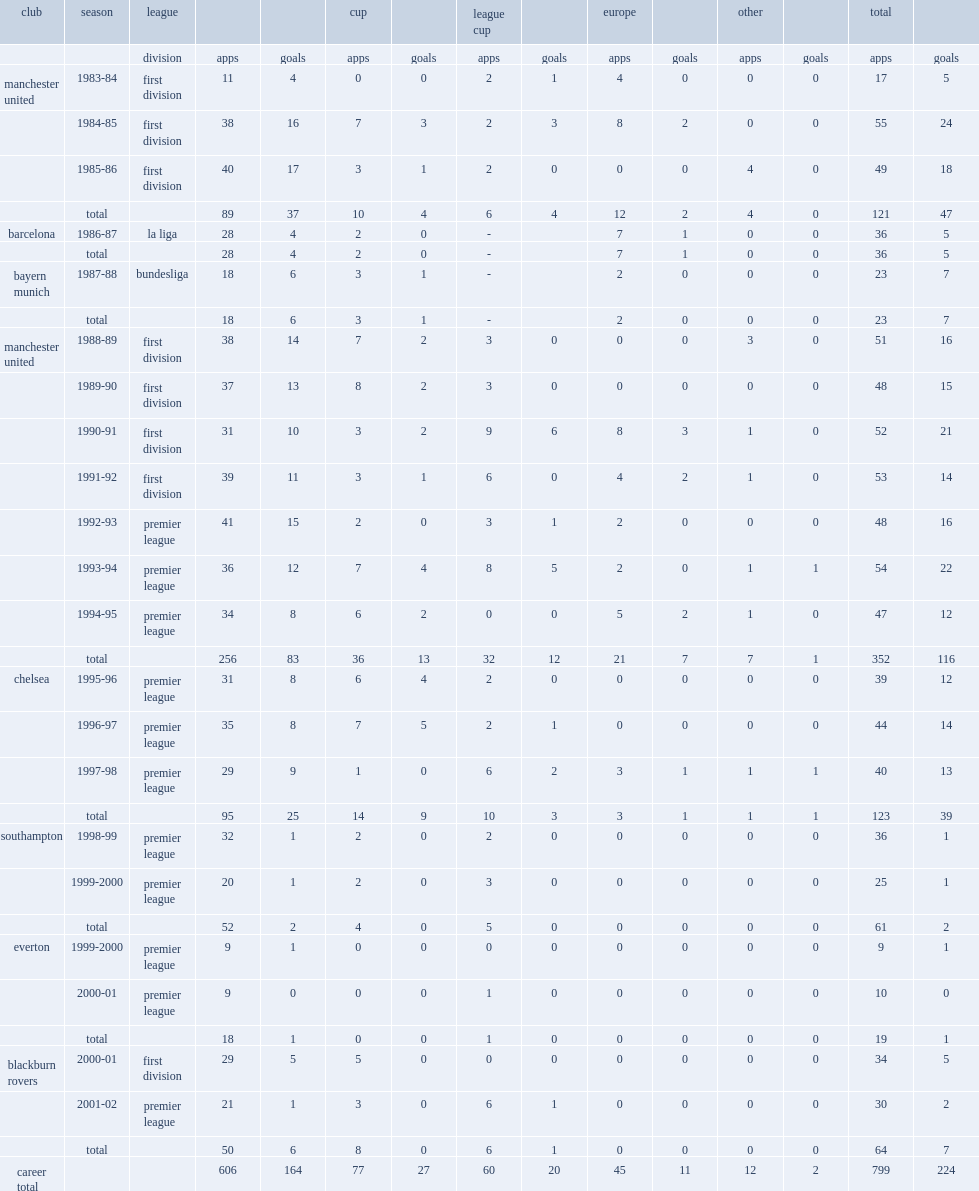Can you parse all the data within this table? {'header': ['club', 'season', 'league', '', '', 'cup', '', 'league cup', '', 'europe', '', 'other', '', 'total', ''], 'rows': [['', '', 'division', 'apps', 'goals', 'apps', 'goals', 'apps', 'goals', 'apps', 'goals', 'apps', 'goals', 'apps', 'goals'], ['manchester united', '1983-84', 'first division', '11', '4', '0', '0', '2', '1', '4', '0', '0', '0', '17', '5'], ['', '1984-85', 'first division', '38', '16', '7', '3', '2', '3', '8', '2', '0', '0', '55', '24'], ['', '1985-86', 'first division', '40', '17', '3', '1', '2', '0', '0', '0', '4', '0', '49', '18'], ['', 'total', '', '89', '37', '10', '4', '6', '4', '12', '2', '4', '0', '121', '47'], ['barcelona', '1986-87', 'la liga', '28', '4', '2', '0', '-', '', '7', '1', '0', '0', '36', '5'], ['', 'total', '', '28', '4', '2', '0', '-', '', '7', '1', '0', '0', '36', '5'], ['bayern munich', '1987-88', 'bundesliga', '18', '6', '3', '1', '-', '', '2', '0', '0', '0', '23', '7'], ['', 'total', '', '18', '6', '3', '1', '-', '', '2', '0', '0', '0', '23', '7'], ['manchester united', '1988-89', 'first division', '38', '14', '7', '2', '3', '0', '0', '0', '3', '0', '51', '16'], ['', '1989-90', 'first division', '37', '13', '8', '2', '3', '0', '0', '0', '0', '0', '48', '15'], ['', '1990-91', 'first division', '31', '10', '3', '2', '9', '6', '8', '3', '1', '0', '52', '21'], ['', '1991-92', 'first division', '39', '11', '3', '1', '6', '0', '4', '2', '1', '0', '53', '14'], ['', '1992-93', 'premier league', '41', '15', '2', '0', '3', '1', '2', '0', '0', '0', '48', '16'], ['', '1993-94', 'premier league', '36', '12', '7', '4', '8', '5', '2', '0', '1', '1', '54', '22'], ['', '1994-95', 'premier league', '34', '8', '6', '2', '0', '0', '5', '2', '1', '0', '47', '12'], ['', 'total', '', '256', '83', '36', '13', '32', '12', '21', '7', '7', '1', '352', '116'], ['chelsea', '1995-96', 'premier league', '31', '8', '6', '4', '2', '0', '0', '0', '0', '0', '39', '12'], ['', '1996-97', 'premier league', '35', '8', '7', '5', '2', '1', '0', '0', '0', '0', '44', '14'], ['', '1997-98', 'premier league', '29', '9', '1', '0', '6', '2', '3', '1', '1', '1', '40', '13'], ['', 'total', '', '95', '25', '14', '9', '10', '3', '3', '1', '1', '1', '123', '39'], ['southampton', '1998-99', 'premier league', '32', '1', '2', '0', '2', '0', '0', '0', '0', '0', '36', '1'], ['', '1999-2000', 'premier league', '20', '1', '2', '0', '3', '0', '0', '0', '0', '0', '25', '1'], ['', 'total', '', '52', '2', '4', '0', '5', '0', '0', '0', '0', '0', '61', '2'], ['everton', '1999-2000', 'premier league', '9', '1', '0', '0', '0', '0', '0', '0', '0', '0', '9', '1'], ['', '2000-01', 'premier league', '9', '0', '0', '0', '1', '0', '0', '0', '0', '0', '10', '0'], ['', 'total', '', '18', '1', '0', '0', '1', '0', '0', '0', '0', '0', '19', '1'], ['blackburn rovers', '2000-01', 'first division', '29', '5', '5', '0', '0', '0', '0', '0', '0', '0', '34', '5'], ['', '2001-02', 'premier league', '21', '1', '3', '0', '6', '1', '0', '0', '0', '0', '30', '2'], ['', 'total', '', '50', '6', '8', '0', '6', '1', '0', '0', '0', '0', '64', '7'], ['career total', '', '', '606', '164', '77', '27', '60', '20', '45', '11', '12', '2', '799', '224']]} Which club did hughes play for in 1995-96? Chelsea. 